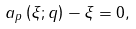Convert formula to latex. <formula><loc_0><loc_0><loc_500><loc_500>a _ { p } \left ( \xi ; q \right ) - \xi = 0 ,</formula> 